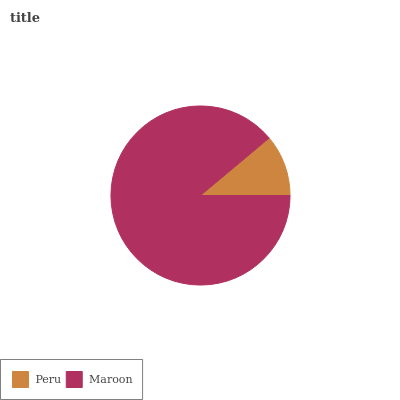Is Peru the minimum?
Answer yes or no. Yes. Is Maroon the maximum?
Answer yes or no. Yes. Is Maroon the minimum?
Answer yes or no. No. Is Maroon greater than Peru?
Answer yes or no. Yes. Is Peru less than Maroon?
Answer yes or no. Yes. Is Peru greater than Maroon?
Answer yes or no. No. Is Maroon less than Peru?
Answer yes or no. No. Is Maroon the high median?
Answer yes or no. Yes. Is Peru the low median?
Answer yes or no. Yes. Is Peru the high median?
Answer yes or no. No. Is Maroon the low median?
Answer yes or no. No. 